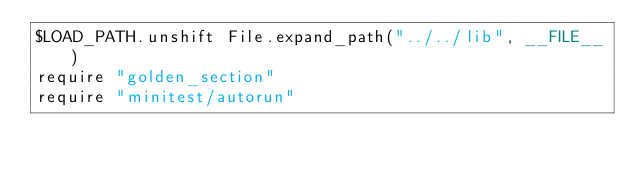<code> <loc_0><loc_0><loc_500><loc_500><_Ruby_>$LOAD_PATH.unshift File.expand_path("../../lib", __FILE__)
require "golden_section"
require "minitest/autorun"</code> 